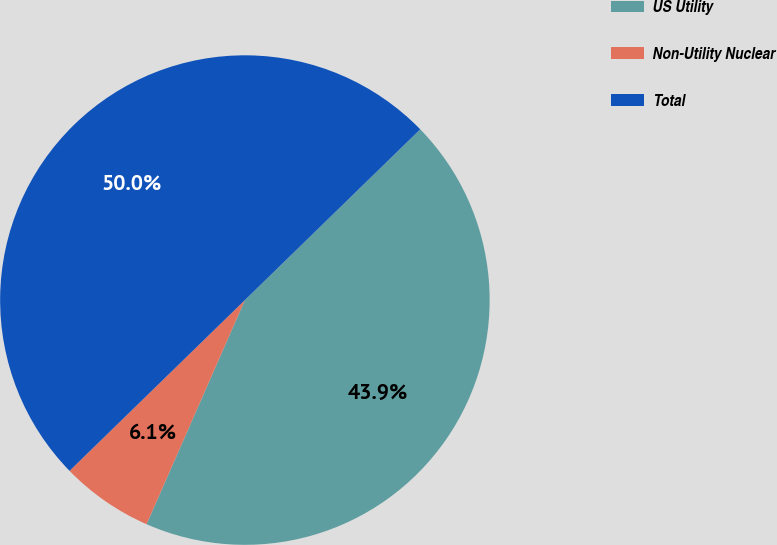Convert chart. <chart><loc_0><loc_0><loc_500><loc_500><pie_chart><fcel>US Utility<fcel>Non-Utility Nuclear<fcel>Total<nl><fcel>43.87%<fcel>6.13%<fcel>50.0%<nl></chart> 